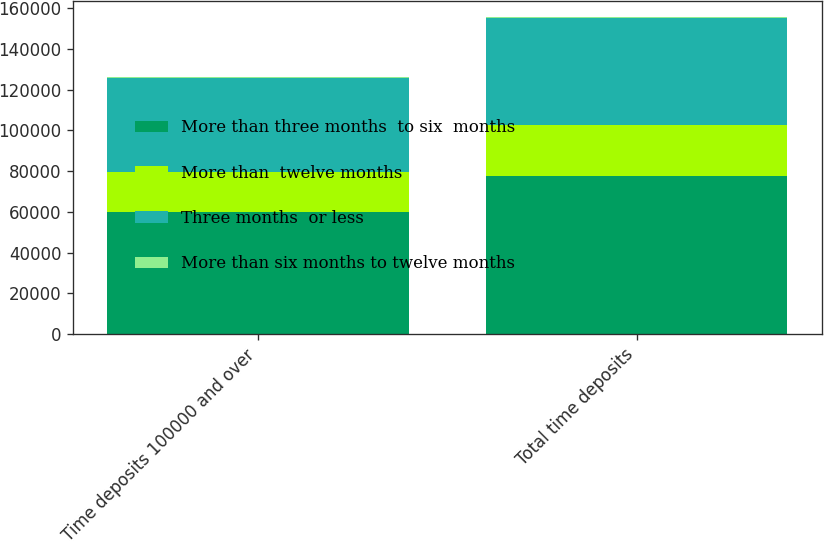<chart> <loc_0><loc_0><loc_500><loc_500><stacked_bar_chart><ecel><fcel>Time deposits 100000 and over<fcel>Total time deposits<nl><fcel>More than three months  to six  months<fcel>59703<fcel>77653<nl><fcel>More than  twelve months<fcel>19952<fcel>25205<nl><fcel>Three months  or less<fcel>45947<fcel>52491<nl><fcel>More than six months to twelve months<fcel>400<fcel>400<nl></chart> 